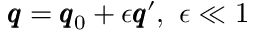<formula> <loc_0><loc_0><loc_500><loc_500>\pm b q = \pm b q _ { 0 } + \epsilon \pm b q ^ { \prime } , \ \epsilon \ll 1</formula> 